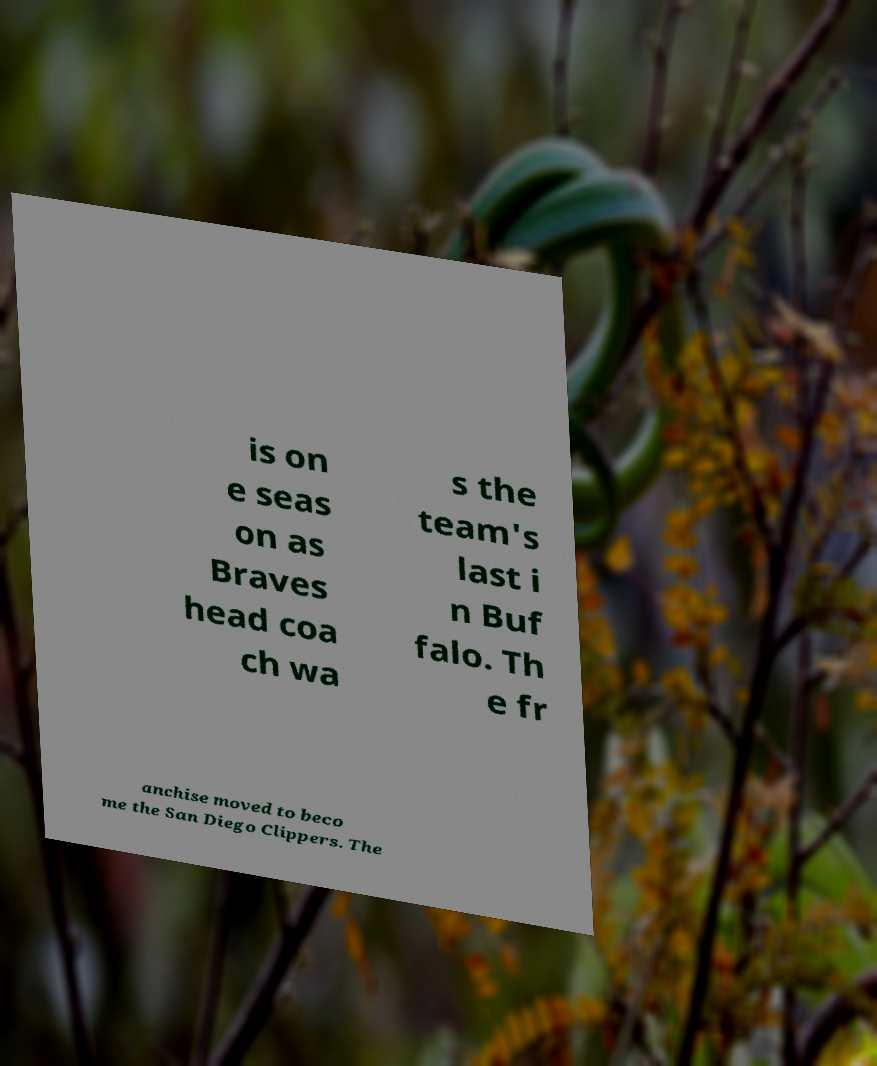Please read and relay the text visible in this image. What does it say? is on e seas on as Braves head coa ch wa s the team's last i n Buf falo. Th e fr anchise moved to beco me the San Diego Clippers. The 